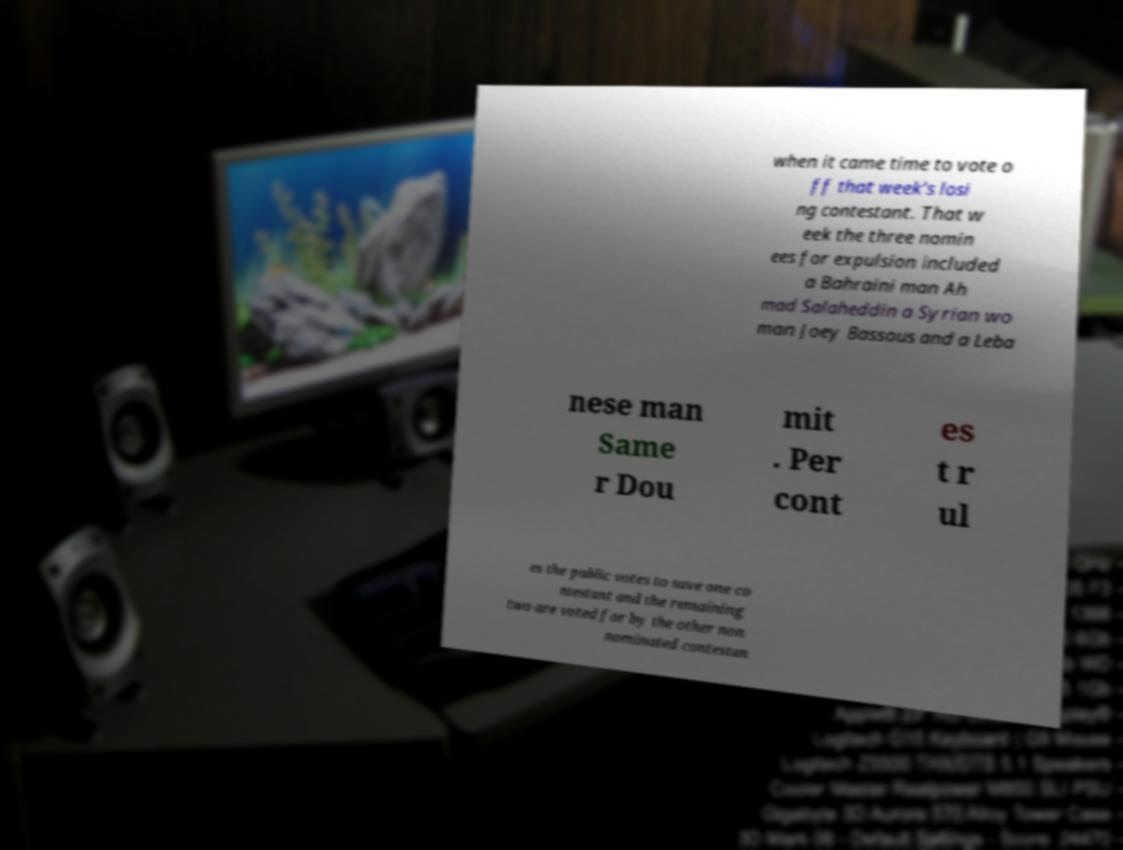Can you read and provide the text displayed in the image?This photo seems to have some interesting text. Can you extract and type it out for me? when it came time to vote o ff that week's losi ng contestant. That w eek the three nomin ees for expulsion included a Bahraini man Ah mad Salaheddin a Syrian wo man Joey Bassous and a Leba nese man Same r Dou mit . Per cont es t r ul es the public votes to save one co ntestant and the remaining two are voted for by the other non nominated contestan 